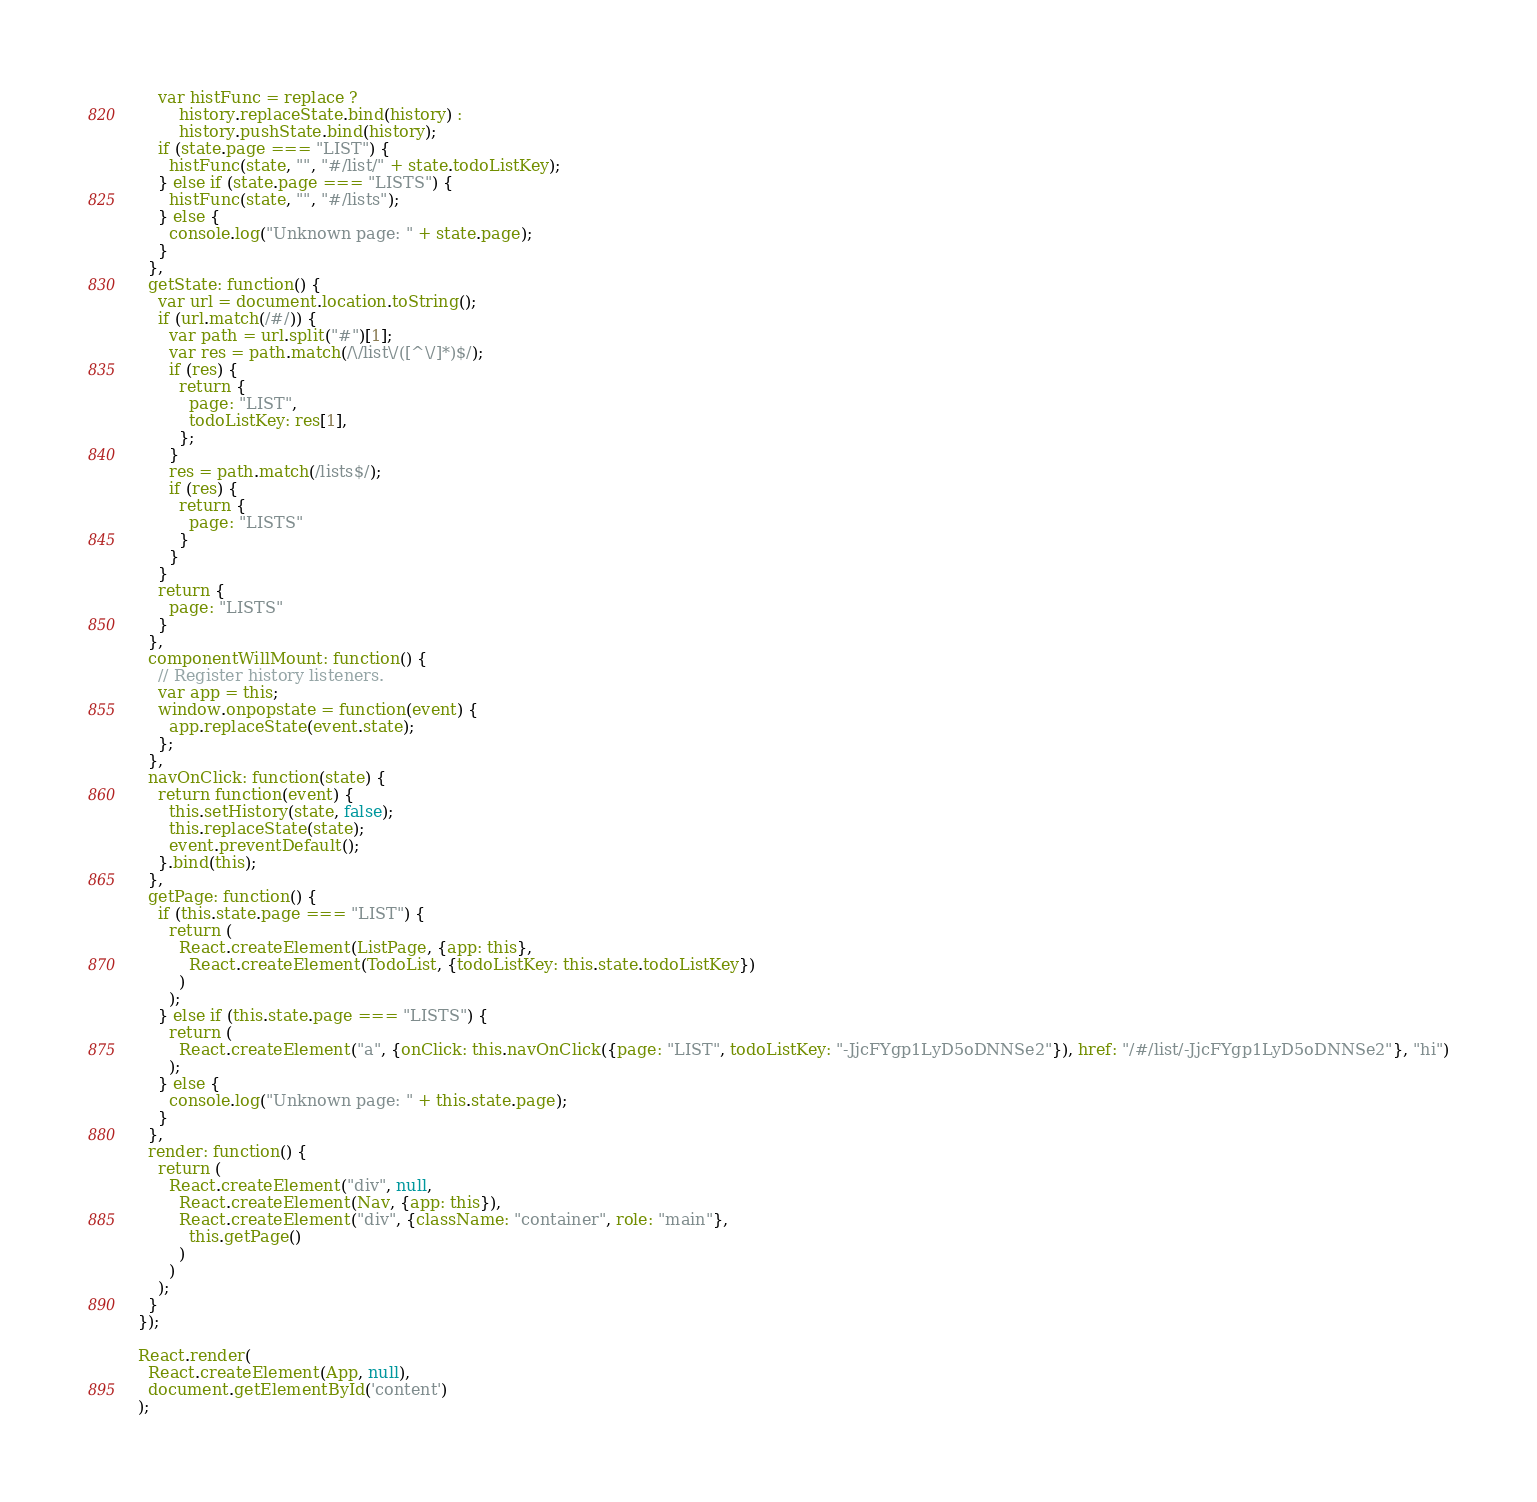<code> <loc_0><loc_0><loc_500><loc_500><_JavaScript_>
    var histFunc = replace ?
        history.replaceState.bind(history) :
        history.pushState.bind(history);
    if (state.page === "LIST") {
      histFunc(state, "", "#/list/" + state.todoListKey);
    } else if (state.page === "LISTS") {
      histFunc(state, "", "#/lists");
    } else {
      console.log("Unknown page: " + state.page);
    }
  },
  getState: function() {
    var url = document.location.toString();
    if (url.match(/#/)) {
      var path = url.split("#")[1];
      var res = path.match(/\/list\/([^\/]*)$/);
      if (res) {
        return {
          page: "LIST",
          todoListKey: res[1],
        };
      }
      res = path.match(/lists$/);
      if (res) {
        return {
          page: "LISTS"
        }
      }
    }
    return {
      page: "LISTS"
    }
  },
  componentWillMount: function() {
    // Register history listeners.
    var app = this;
    window.onpopstate = function(event) {
      app.replaceState(event.state);
    };
  },
  navOnClick: function(state) {
    return function(event) {
      this.setHistory(state, false);
      this.replaceState(state);
      event.preventDefault();
    }.bind(this);
  },
  getPage: function() {
    if (this.state.page === "LIST") {
      return (
        React.createElement(ListPage, {app: this}, 
          React.createElement(TodoList, {todoListKey: this.state.todoListKey})
        )
      );
    } else if (this.state.page === "LISTS") {
      return (
        React.createElement("a", {onClick: this.navOnClick({page: "LIST", todoListKey: "-JjcFYgp1LyD5oDNNSe2"}), href: "/#/list/-JjcFYgp1LyD5oDNNSe2"}, "hi")
      );
    } else {
      console.log("Unknown page: " + this.state.page);
    }
  },
  render: function() {
    return (
      React.createElement("div", null, 
        React.createElement(Nav, {app: this}), 
        React.createElement("div", {className: "container", role: "main"}, 
          this.getPage()
        )
      )
    );
  }
});

React.render(
  React.createElement(App, null),
  document.getElementById('content')
);</code> 